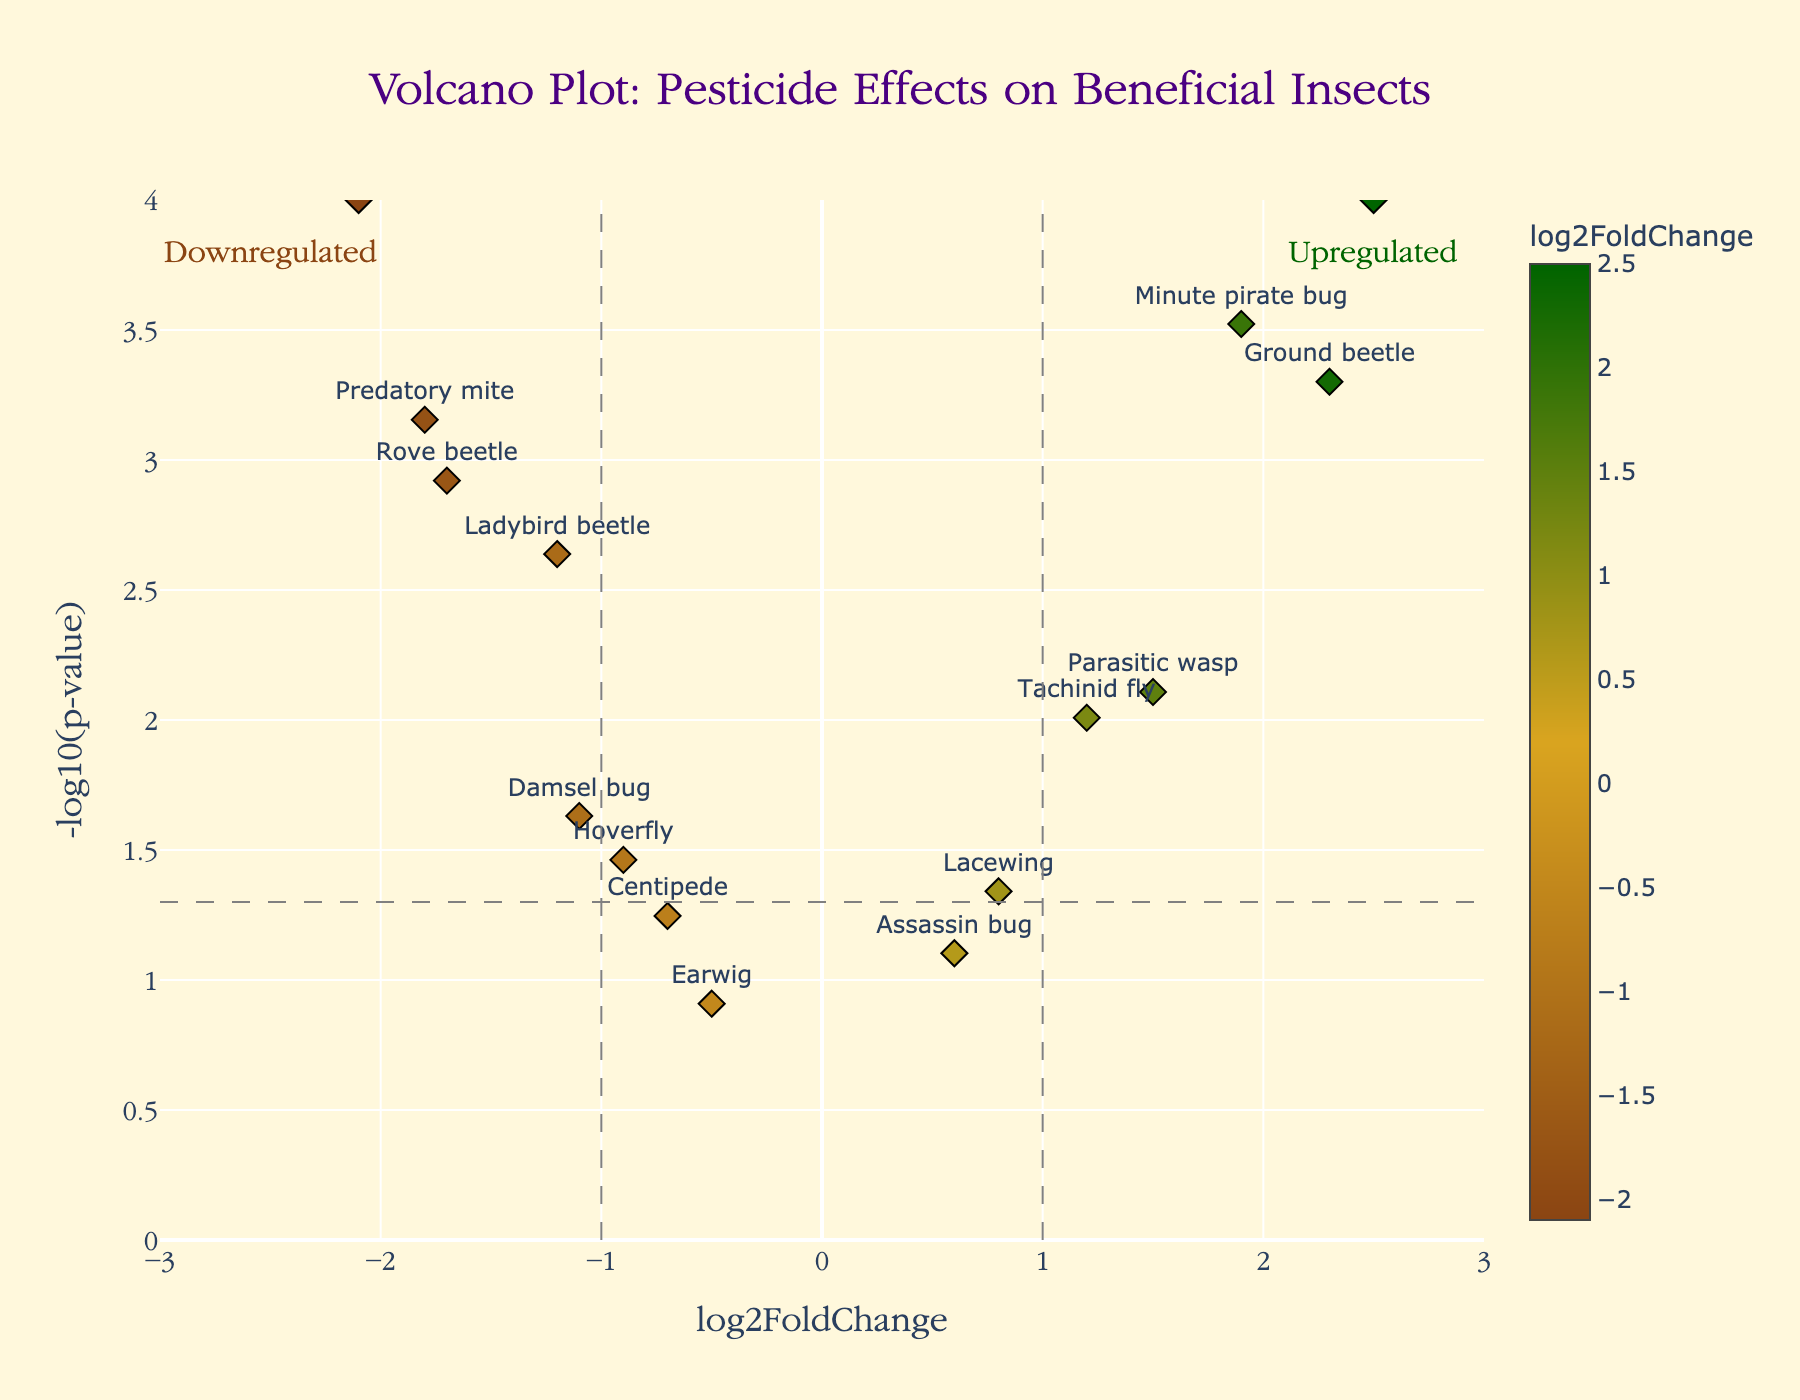What's the title of the figure? The title of the figure is centered at the top, displayed in a distinct font and color, indicating the main subject of the Volcano Plot.
Answer: Volcano Plot: Pesticide Effects on Beneficial Insects What are the labels on the x-axis and y-axis? The x-axis label is depicted horizontally at the bottom, indicating the 'log2FoldChange', while the y-axis label, displayed vertically, represents '-log10(p-value)'.
Answer: x-axis: log2FoldChange, y-axis: -log10(p-value) How many insect species show a significant change in population with a p-value less than 0.05? By looking at the horizontal line set at -log10(p-value) = 1.3 (p-value = 0.05), we count the number of points above this line. The species above this line are Ladybird beetle, Praying mantis, Parasitic wasp, Hoverfly, Ground beetle, Rove beetle, Damsel bug, Minute pirate bug, Tachinid fly, Predatory mite, and Spider.
Answer: 11 What insect shows the highest log2FoldChange, and what is its value? Observing the x-axis, the insect farthest to the right represents the highest log2FoldChange. This is the Spider, with a log2FoldChange value of 2.5.
Answer: Spider, 2.5 Which insects are significantly downregulated? Downregulated insects are those with log2FoldChange < -1 and -log10(p-value) > 1.3. They include Ladybird beetle, Praying mantis, Rove beetle, and Predatory mite.
Answer: Ladybird beetle, Praying mantis, Rove beetle, Predatory mite Are there more insects upregulated or downregulated? To determine this, we count the insects with log2FoldChange > 1 (upregulated) and log2FoldChange < -1 (downregulated). Upregulated insects include Parasitic wasp, Ground beetle, Minute pirate bug, Tachinid fly, and Spider (5). Downregulated insects are Ladybird beetle, Praying mantis, Rove beetle, and Predatory mite (4).
Answer: More upregulated What is the range of data on the y-axis? The y-axis ranges from 0 to 4 as shown by the ticks on the vertical axis.
Answer: 0 to 4 Among the insects with a p-value less than 0.001, which one has the lowest log2FoldChange? Examining the data points above the -log10(p-value) line for p-value less than 0.001, find the insect with the smallest log2FoldChange. Rove beetle has a log2FoldChange of -1.7.
Answer: Rove beetle 